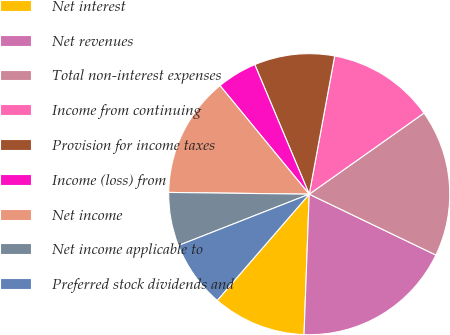Convert chart to OTSL. <chart><loc_0><loc_0><loc_500><loc_500><pie_chart><fcel>Net interest<fcel>Net revenues<fcel>Total non-interest expenses<fcel>Income from continuing<fcel>Provision for income taxes<fcel>Income (loss) from<fcel>Net income<fcel>Net income applicable to<fcel>Preferred stock dividends and<nl><fcel>10.77%<fcel>18.46%<fcel>16.92%<fcel>12.31%<fcel>9.23%<fcel>4.62%<fcel>13.85%<fcel>6.15%<fcel>7.69%<nl></chart> 